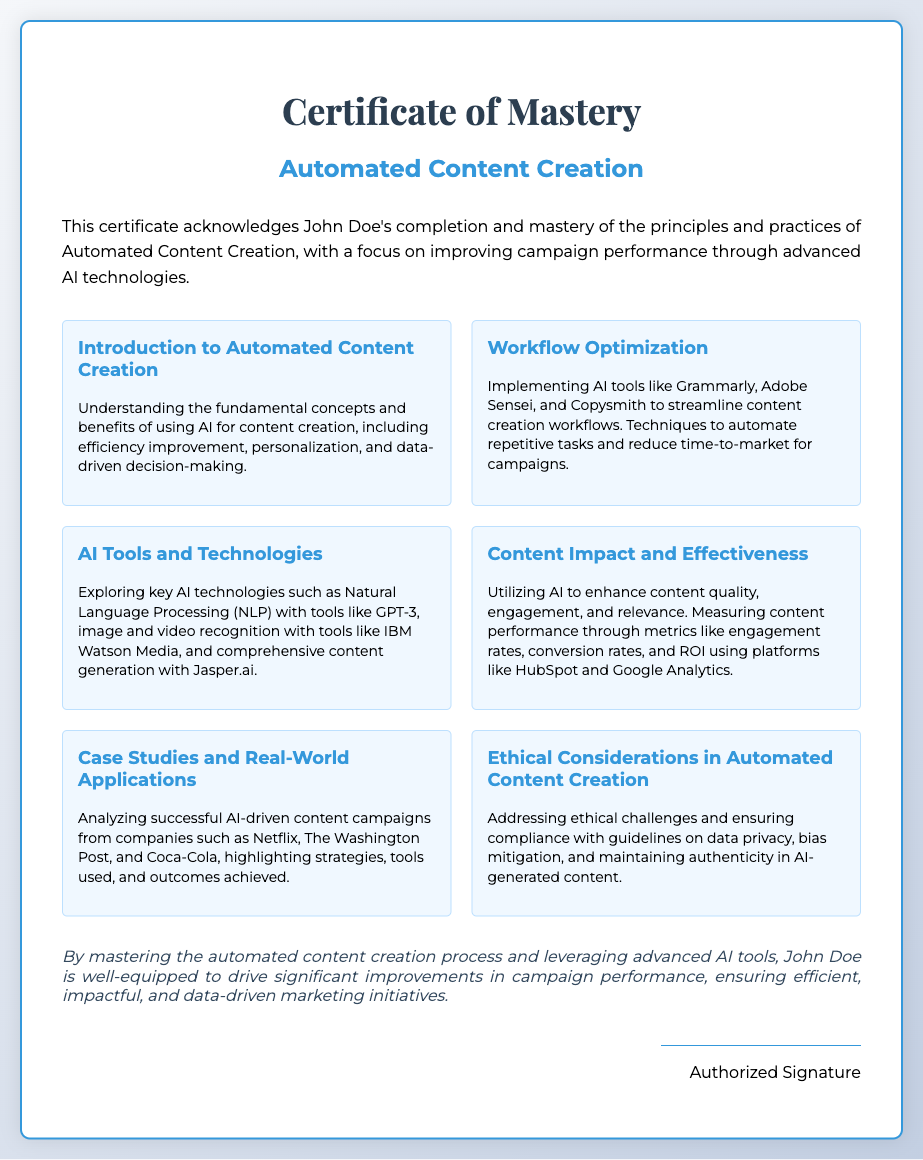What is the name of the certificate? The name of the certificate is stated at the top of the document.
Answer: Certificate of Mastery Who completed the mastery in Automated Content Creation? The recipient of the certificate is mentioned in the description section.
Answer: John Doe What is one AI tool mentioned for workflow optimization? The document lists specific tools used for streamlining content creation workflows.
Answer: Grammarly What key technology is explored in the AI Tools and Technologies module? This technology is referenced in relation to the tools and their applications in content creation.
Answer: Natural Language Processing Which company is mentioned as an example in the Case Studies module? The document highlights successful AI-driven content campaigns from notable companies.
Answer: Netflix What is one of the ethical considerations discussed in the course? Ethical challenges related to AI-generated content are addressed in a specific module.
Answer: Data privacy What is the focus of the Content Impact and Effectiveness module? The purpose of the module is indicated by its title and its content description.
Answer: Enhancing content quality What is the primary benefit of mastering automated content creation stated in the conclusion? The conclusion outlines the impact of mastering automated content creation on campaign initiatives.
Answer: Drive significant improvements in campaign performance 